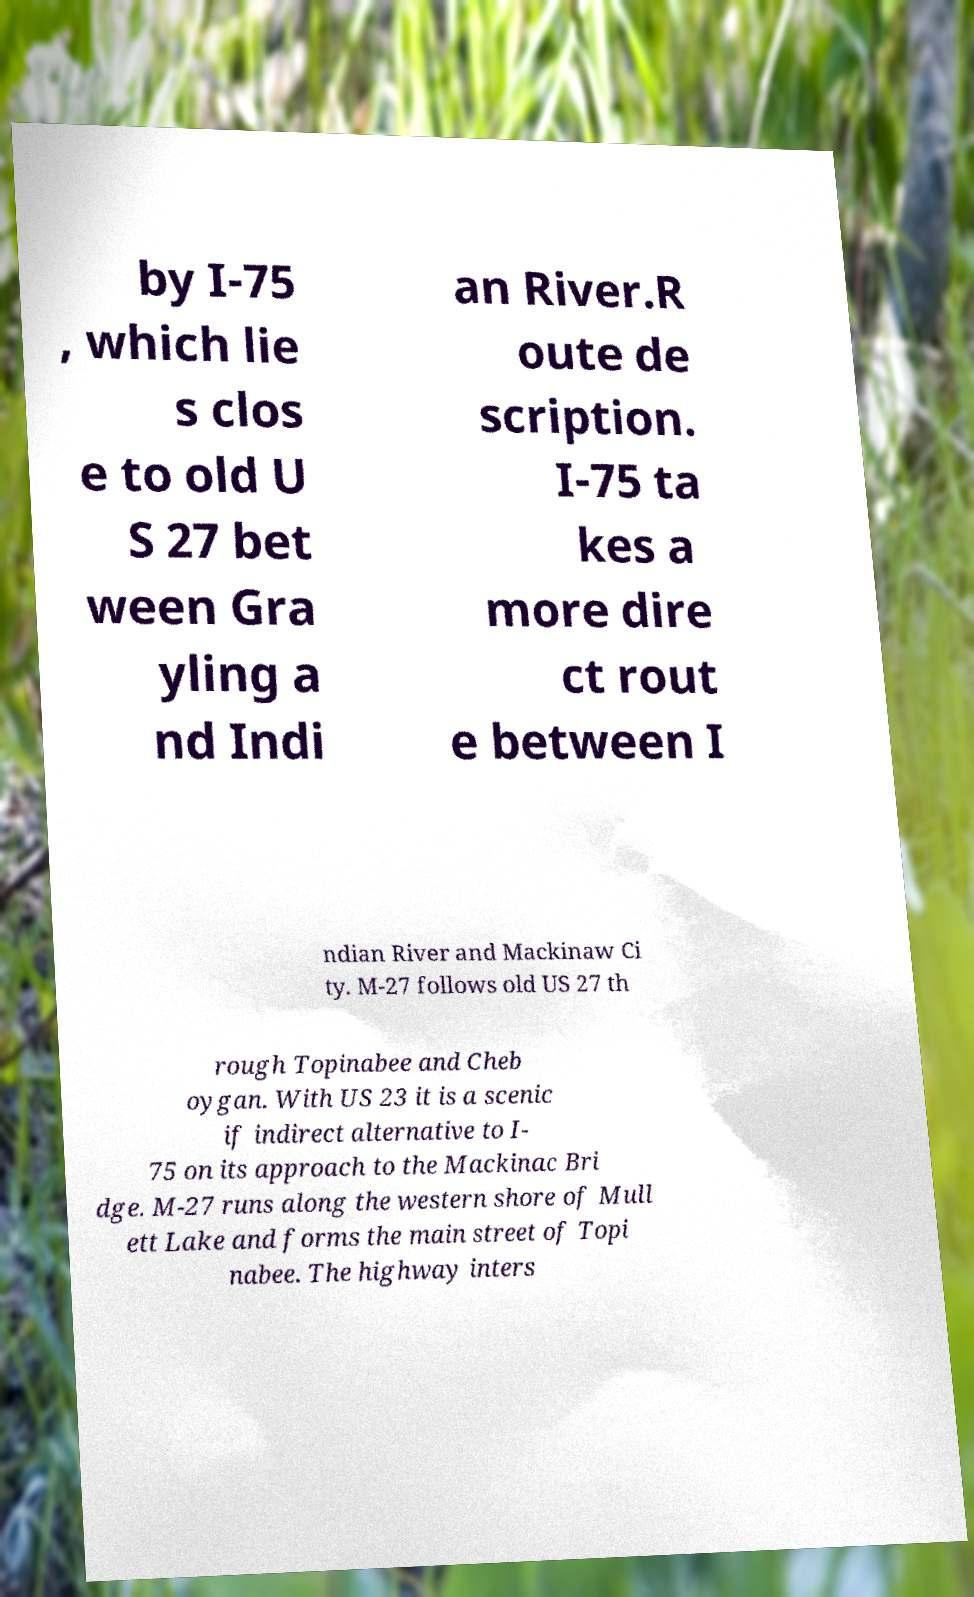There's text embedded in this image that I need extracted. Can you transcribe it verbatim? by I-75 , which lie s clos e to old U S 27 bet ween Gra yling a nd Indi an River.R oute de scription. I-75 ta kes a more dire ct rout e between I ndian River and Mackinaw Ci ty. M-27 follows old US 27 th rough Topinabee and Cheb oygan. With US 23 it is a scenic if indirect alternative to I- 75 on its approach to the Mackinac Bri dge. M-27 runs along the western shore of Mull ett Lake and forms the main street of Topi nabee. The highway inters 